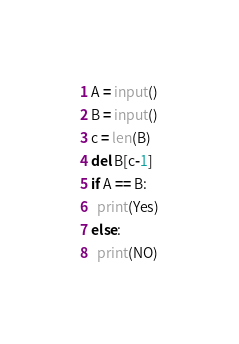Convert code to text. <code><loc_0><loc_0><loc_500><loc_500><_Python_>A = input()
B = input()
c = len(B)
del B[c-1]
if A == B:
  print(Yes)
else:
  print(NO)
</code> 